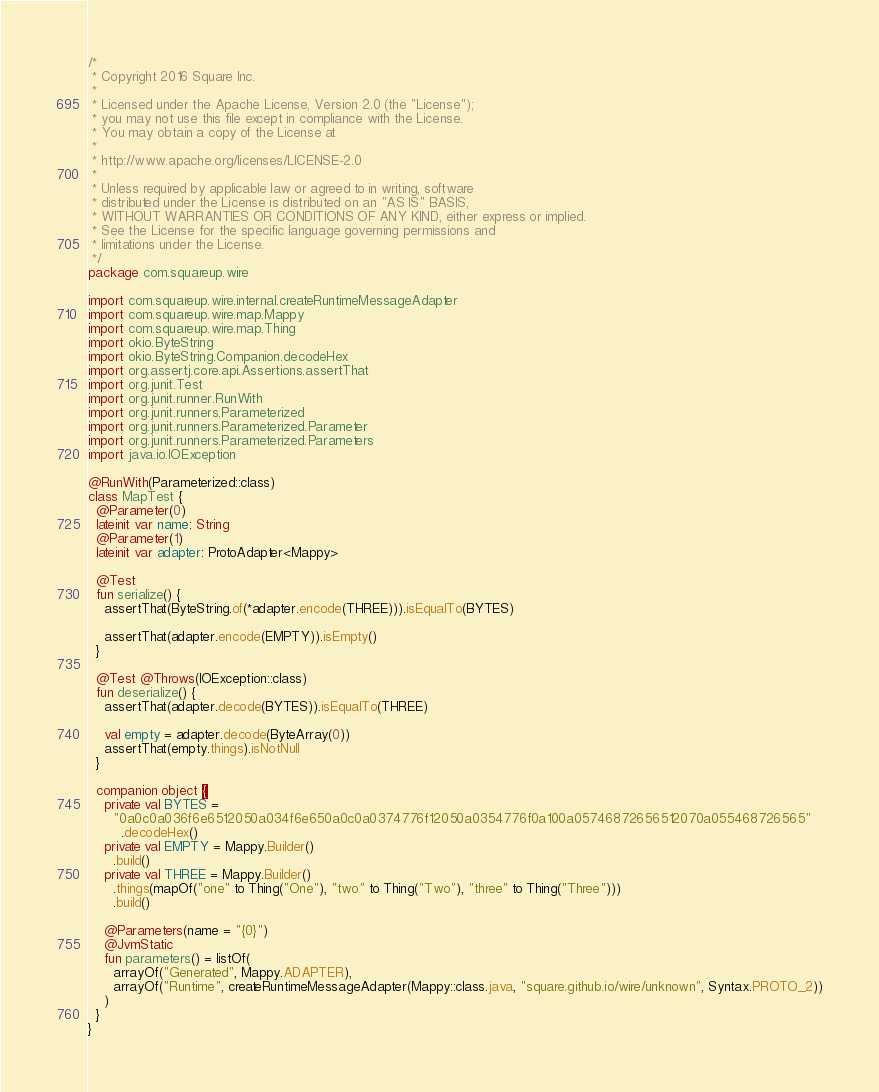<code> <loc_0><loc_0><loc_500><loc_500><_Kotlin_>/*
 * Copyright 2016 Square Inc.
 *
 * Licensed under the Apache License, Version 2.0 (the "License");
 * you may not use this file except in compliance with the License.
 * You may obtain a copy of the License at
 *
 * http://www.apache.org/licenses/LICENSE-2.0
 *
 * Unless required by applicable law or agreed to in writing, software
 * distributed under the License is distributed on an "AS IS" BASIS,
 * WITHOUT WARRANTIES OR CONDITIONS OF ANY KIND, either express or implied.
 * See the License for the specific language governing permissions and
 * limitations under the License.
 */
package com.squareup.wire

import com.squareup.wire.internal.createRuntimeMessageAdapter
import com.squareup.wire.map.Mappy
import com.squareup.wire.map.Thing
import okio.ByteString
import okio.ByteString.Companion.decodeHex
import org.assertj.core.api.Assertions.assertThat
import org.junit.Test
import org.junit.runner.RunWith
import org.junit.runners.Parameterized
import org.junit.runners.Parameterized.Parameter
import org.junit.runners.Parameterized.Parameters
import java.io.IOException

@RunWith(Parameterized::class)
class MapTest {
  @Parameter(0)
  lateinit var name: String
  @Parameter(1)
  lateinit var adapter: ProtoAdapter<Mappy>

  @Test
  fun serialize() {
    assertThat(ByteString.of(*adapter.encode(THREE))).isEqualTo(BYTES)

    assertThat(adapter.encode(EMPTY)).isEmpty()
  }

  @Test @Throws(IOException::class)
  fun deserialize() {
    assertThat(adapter.decode(BYTES)).isEqualTo(THREE)

    val empty = adapter.decode(ByteArray(0))
    assertThat(empty.things).isNotNull
  }

  companion object {
    private val BYTES =
      "0a0c0a036f6e6512050a034f6e650a0c0a0374776f12050a0354776f0a100a05746872656512070a055468726565"
        .decodeHex()
    private val EMPTY = Mappy.Builder()
      .build()
    private val THREE = Mappy.Builder()
      .things(mapOf("one" to Thing("One"), "two" to Thing("Two"), "three" to Thing("Three")))
      .build()

    @Parameters(name = "{0}")
    @JvmStatic
    fun parameters() = listOf(
      arrayOf("Generated", Mappy.ADAPTER),
      arrayOf("Runtime", createRuntimeMessageAdapter(Mappy::class.java, "square.github.io/wire/unknown", Syntax.PROTO_2))
    )
  }
}
</code> 